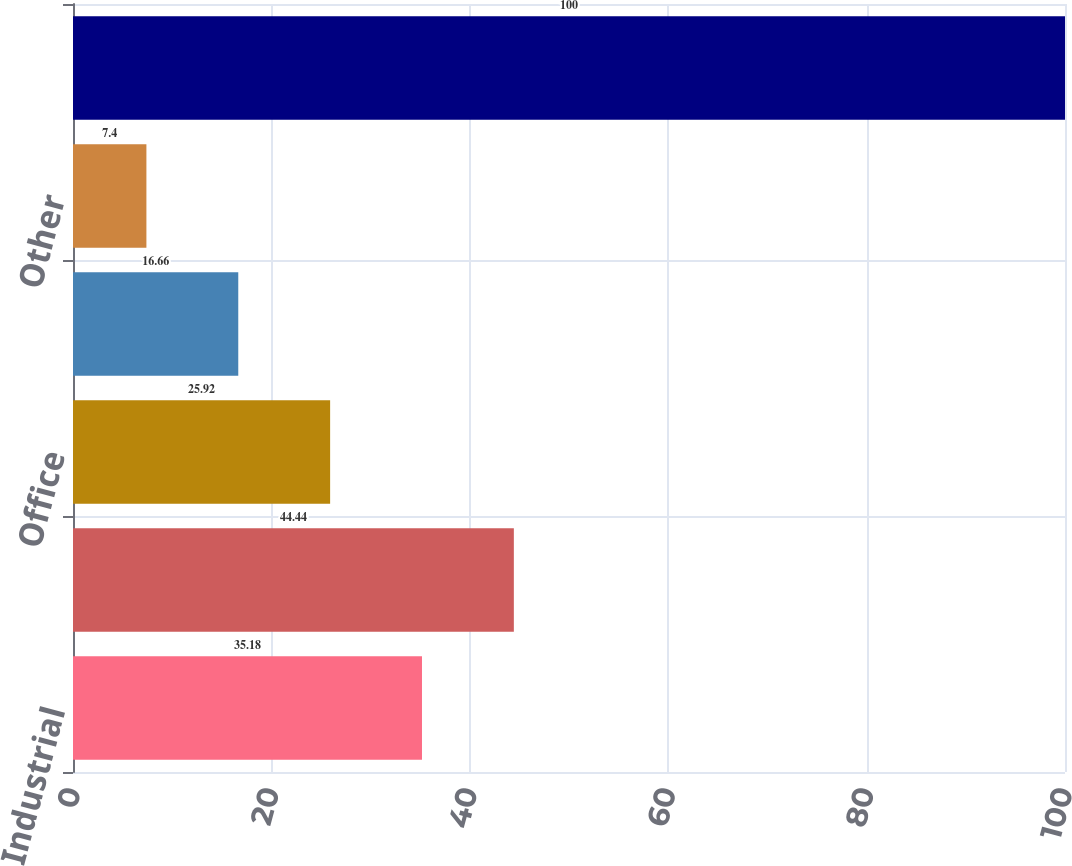<chart> <loc_0><loc_0><loc_500><loc_500><bar_chart><fcel>Industrial<fcel>Multifamily<fcel>Office<fcel>Retail<fcel>Other<fcel>Total mortgage loans<nl><fcel>35.18<fcel>44.44<fcel>25.92<fcel>16.66<fcel>7.4<fcel>100<nl></chart> 